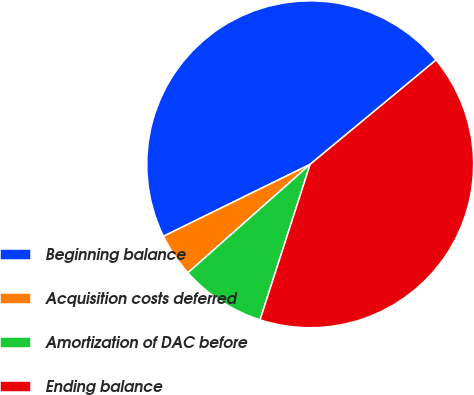Convert chart to OTSL. <chart><loc_0><loc_0><loc_500><loc_500><pie_chart><fcel>Beginning balance<fcel>Acquisition costs deferred<fcel>Amortization of DAC before<fcel>Ending balance<nl><fcel>46.25%<fcel>4.29%<fcel>8.49%<fcel>40.97%<nl></chart> 